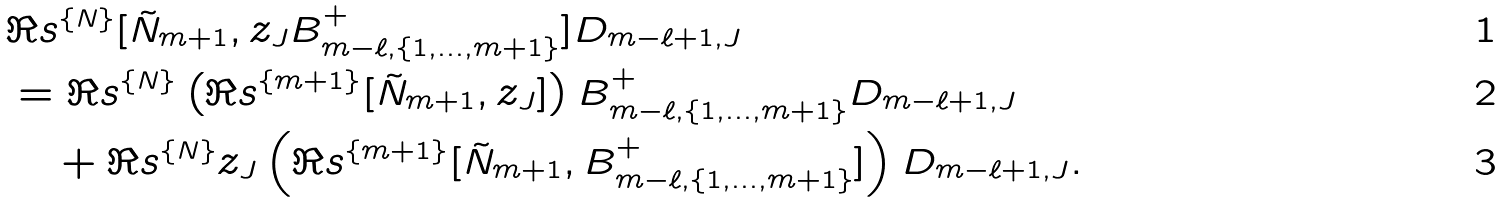<formula> <loc_0><loc_0><loc_500><loc_500>& \Re s ^ { \{ N \} } [ \tilde { N } _ { m + 1 } , z _ { J } B _ { m - \ell , \{ 1 , \dots , m + 1 \} } ^ { + } ] D _ { m - \ell + 1 , J } \\ & = \Re s ^ { \{ N \} } \left ( \Re s ^ { \{ m + 1 \} } [ \tilde { N } _ { m + 1 } , z _ { J } ] \right ) B _ { m - \ell , \{ 1 , \dots , m + 1 \} } ^ { + } D _ { m - \ell + 1 , J } \\ & \quad + \Re s ^ { \{ N \} } z _ { J } \left ( \Re s ^ { \{ m + 1 \} } [ \tilde { N } _ { m + 1 } , B _ { m - \ell , \{ 1 , \dots , m + 1 \} } ^ { + } ] \right ) D _ { m - \ell + 1 , J } .</formula> 